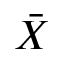<formula> <loc_0><loc_0><loc_500><loc_500>\ B a r { X }</formula> 